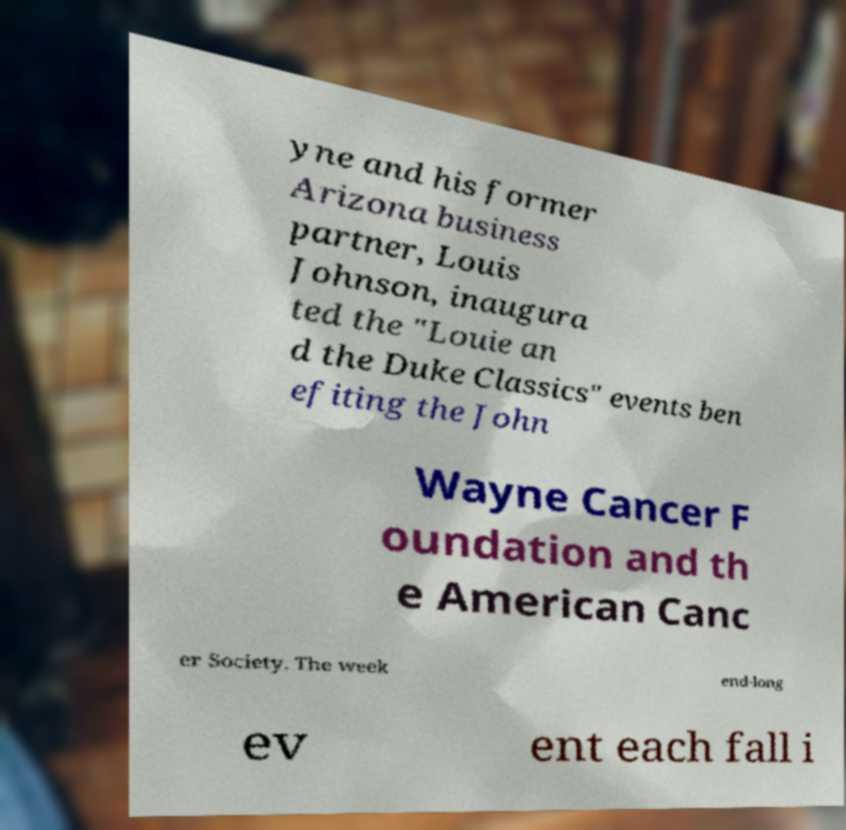Can you read and provide the text displayed in the image?This photo seems to have some interesting text. Can you extract and type it out for me? yne and his former Arizona business partner, Louis Johnson, inaugura ted the "Louie an d the Duke Classics" events ben efiting the John Wayne Cancer F oundation and th e American Canc er Society. The week end-long ev ent each fall i 